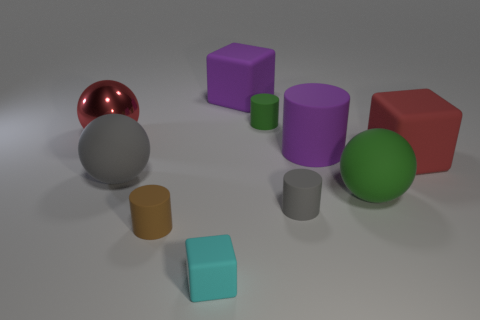Subtract 0 yellow cylinders. How many objects are left? 10 Subtract all cylinders. How many objects are left? 6 Subtract all purple blocks. Subtract all cyan cylinders. How many blocks are left? 2 Subtract all red cylinders. How many red blocks are left? 1 Subtract all big red metal balls. Subtract all big objects. How many objects are left? 3 Add 1 red rubber cubes. How many red rubber cubes are left? 2 Add 3 small blue metallic balls. How many small blue metallic balls exist? 3 Subtract all cyan blocks. How many blocks are left? 2 Subtract all small matte blocks. How many blocks are left? 2 